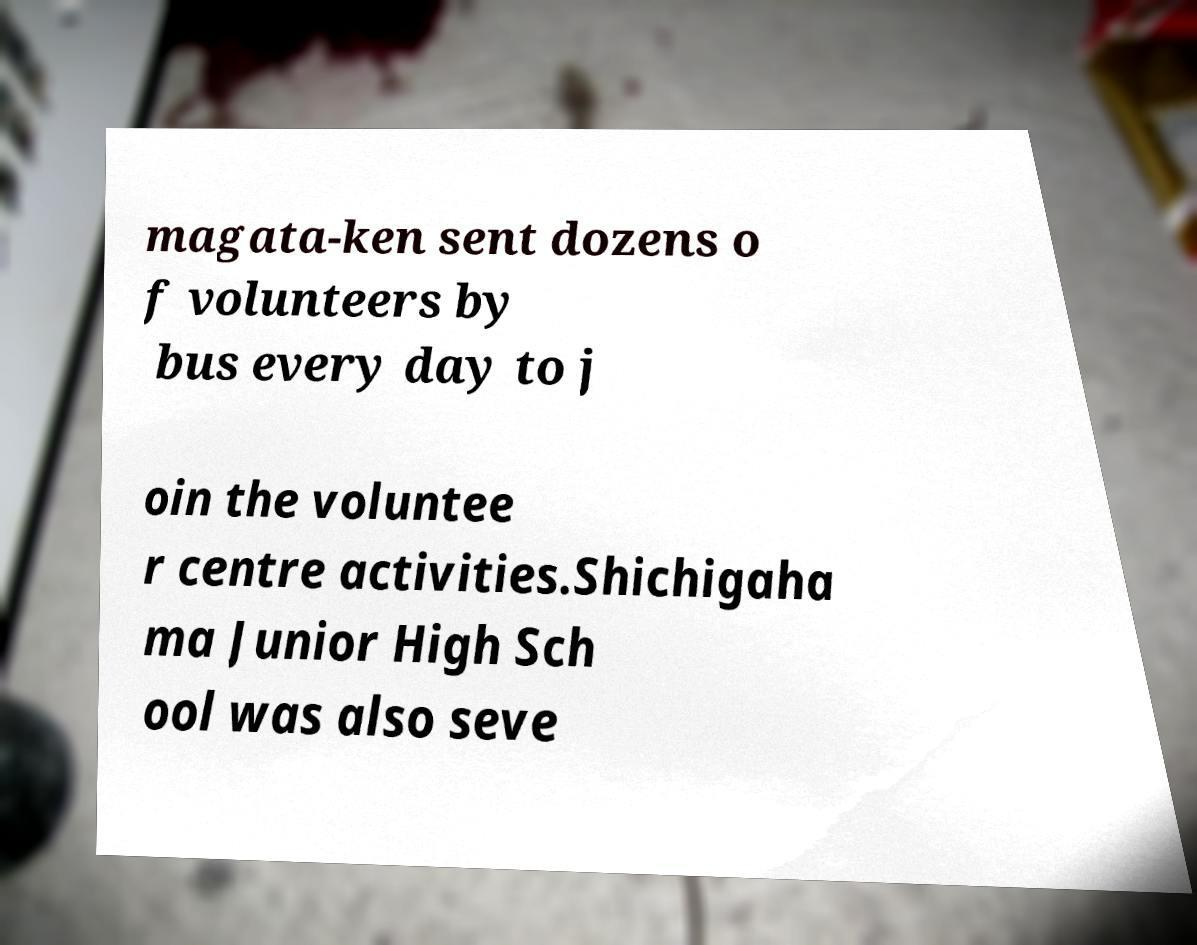What messages or text are displayed in this image? I need them in a readable, typed format. magata-ken sent dozens o f volunteers by bus every day to j oin the voluntee r centre activities.Shichigaha ma Junior High Sch ool was also seve 